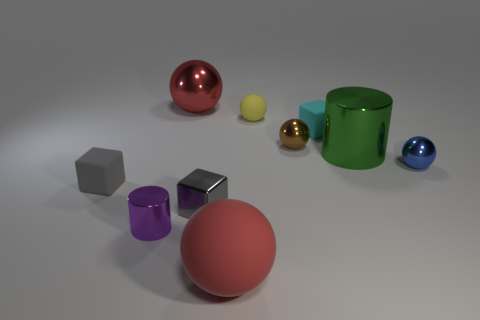Subtract 3 balls. How many balls are left? 2 Subtract all big red rubber spheres. How many spheres are left? 4 Subtract all brown spheres. How many spheres are left? 4 Subtract all gray balls. Subtract all purple cylinders. How many balls are left? 5 Subtract all cubes. How many objects are left? 7 Subtract 0 cyan balls. How many objects are left? 10 Subtract all yellow metallic objects. Subtract all big shiny spheres. How many objects are left? 9 Add 3 balls. How many balls are left? 8 Add 1 big red matte blocks. How many big red matte blocks exist? 1 